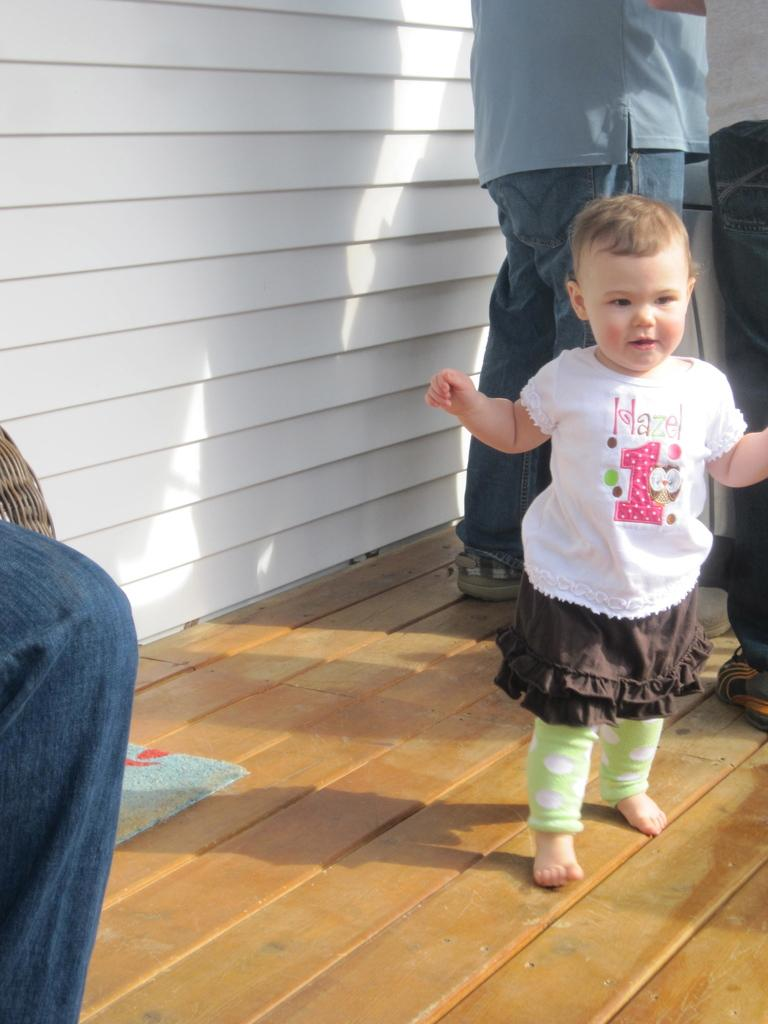What type of surface is visible in the image? There is a wooden surface in the image. What is placed on the wooden surface? There is a mat on the wooden surface. Who is present in the image? There are people in the image, including a kid. What can be seen in the background of the image? There is a white wall in the image. How many hills can be seen in the image? There are no hills visible in the image. What type of stocking is the kid wearing in the image? There is no information about the kid's clothing, including stockings, in the image. 